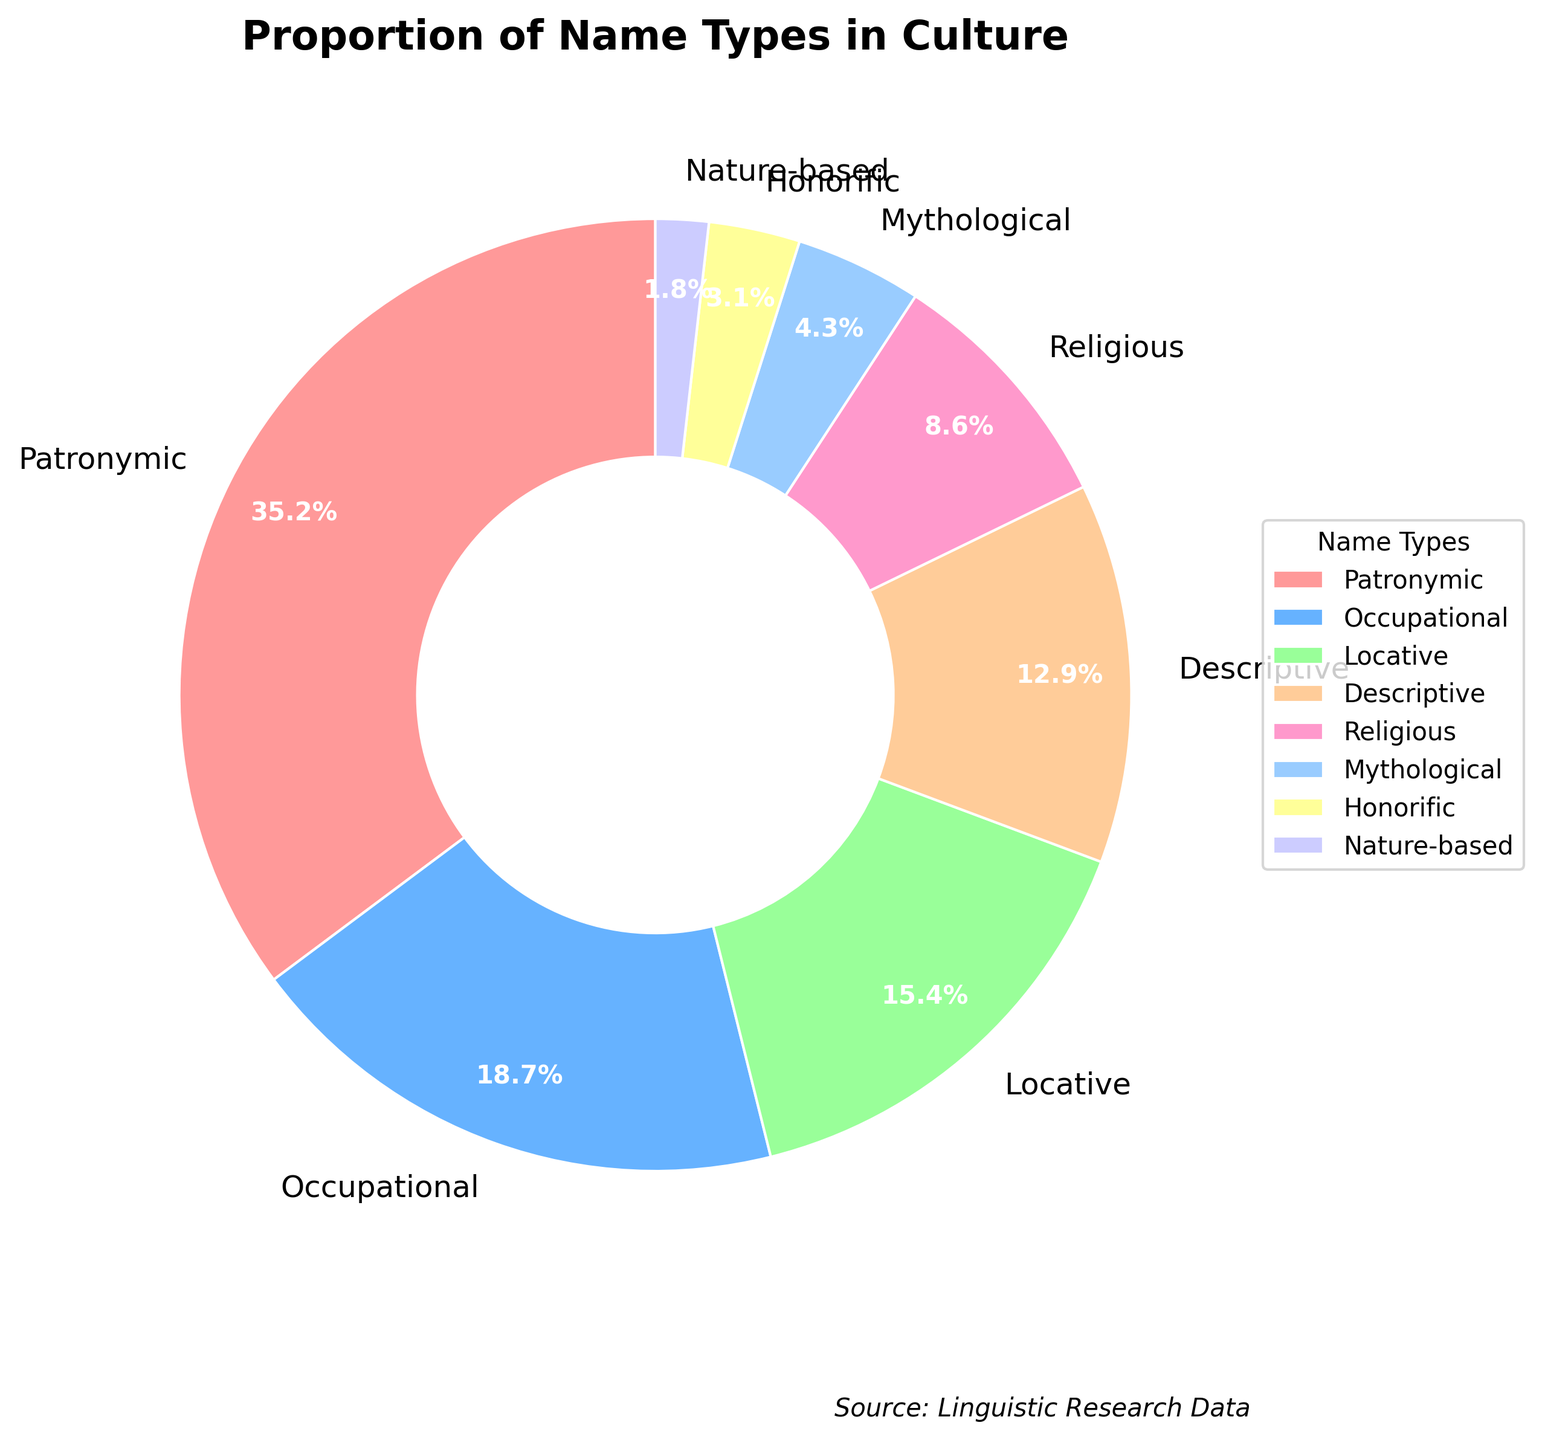What are the two most common types of names in this culture? The two largest slices in the pie chart have "Patronymic" and "Occupational" labels with 35.2% and 18.7%, respectively.
Answer: Patronymic and Occupational What percentage do the nature-based and honorific name types together represent? Sum the percentages of "Nature-based" (1.8%) and "Honorific" (3.1%) from the chart. So, 1.8% + 3.1% = 4.9%.
Answer: 4.9% How much larger is the proportion of locative names compared to honorific names? Subtract the percentage of "Honorific" names (3.1%) from the percentage of "Locative" names (15.4%). So, 15.4% - 3.1% = 12.3%.
Answer: 12.3% Which name type has the least representation, and what is that percentage? The smallest slice in the pie chart is labeled "Nature-based" with a percentage of 1.8%.
Answer: Nature-based, 1.8% How do the combined proportions of descriptive and religious names compare to patronymic names? Add the percentages for "Descriptive" (12.9%) and "Religious" (8.6%) to get 12.9% + 8.6% = 21.5%. Compare this to "Patronymic" (35.2%). 35.2% - 21.5% = 13.7% larger.
Answer: 13.7% larger What is the visual difference in size between the largest and smallest slices? The largest slice corresponds to "Patronymic" at 35.2%, and the smallest slice corresponds to "Nature-based" at 1.8%. Visually, the "Patronymic" slice is significantly larger.
Answer: Patronymic is significantly larger Which name type is represented by the light blue color in the chart? From the visual chart, the light blue color corresponds to the "Occupational" name type.
Answer: Occupational Is the proportion of mythological names greater or smaller than the proportion of religious names? The chart shows "Mythological" names at 4.3% and "Religious" names at 8.6%, so mythological names are smaller.
Answer: Smaller 